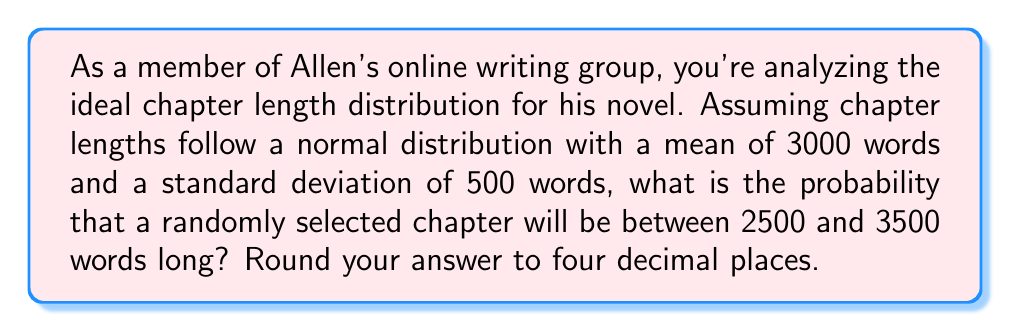Teach me how to tackle this problem. To solve this problem, we'll use the properties of the normal distribution and the concept of z-scores. Let's approach this step-by-step:

1) We're given:
   - Mean (μ) = 3000 words
   - Standard deviation (σ) = 500 words
   - We want to find P(2500 < X < 3500)

2) First, we need to convert the word counts to z-scores:
   For 2500 words: $z_1 = \frac{2500 - 3000}{500} = -1$
   For 3500 words: $z_2 = \frac{3500 - 3000}{500} = 1$

3) Now, we need to find the area under the standard normal curve between z = -1 and z = 1.

4) This can be calculated using the standard normal cumulative distribution function (Φ):
   P(-1 < Z < 1) = Φ(1) - Φ(-1)

5) From standard normal distribution tables or using a calculator:
   Φ(1) ≈ 0.8413
   Φ(-1) ≈ 0.1587

6) Therefore:
   P(-1 < Z < 1) = 0.8413 - 0.1587 = 0.6826

7) Rounding to four decimal places: 0.6826

This means that approximately 68.26% of the chapters in Allen's novel are expected to be between 2500 and 3500 words long, assuming the chapter lengths follow the given normal distribution.
Answer: 0.6826 